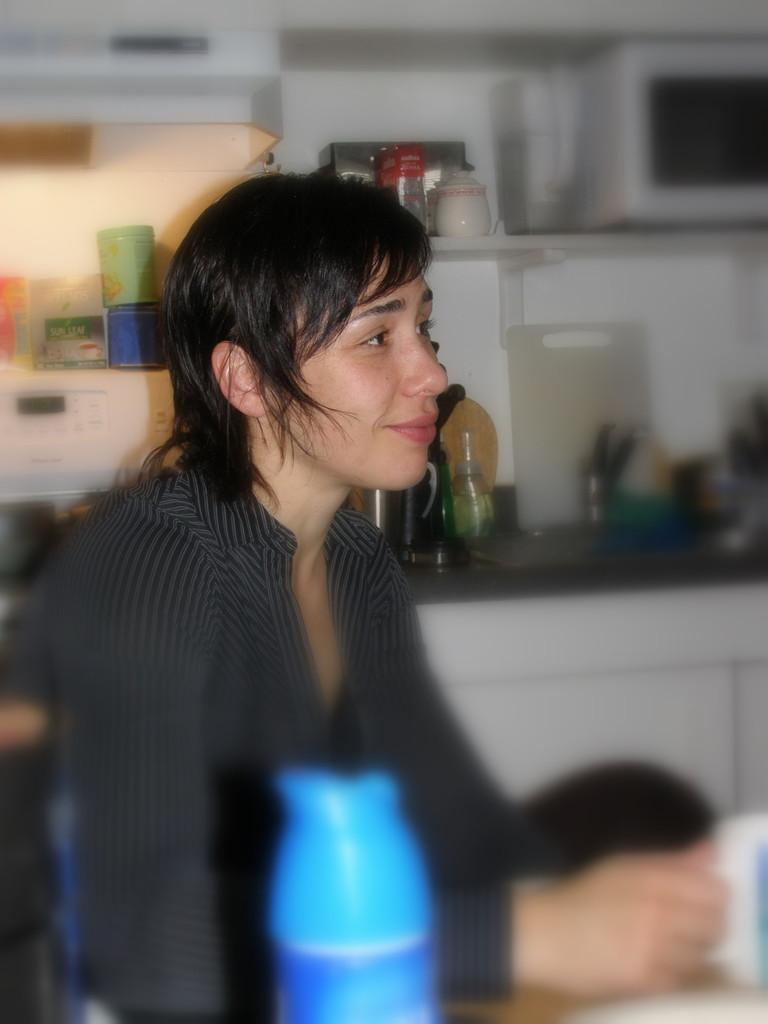What type of image is this? The image is a portrait. Who is the main subject in the portrait? There is a woman in the center of the picture. What is the woman doing in the portrait? The woman is sitting. What object is the woman holding in the portrait? The woman is holding a cup. What can be seen in the background of the portrait? There are bottles, cups, and kitchen utensils in the background. How many trucks are visible in the portrait? There are no trucks visible in the portrait; it is a portrait of a woman sitting and holding a cup. What color is the bead that the woman is wearing in the portrait? There is no bead mentioned or visible in the portrait; the woman is holding a cup. 